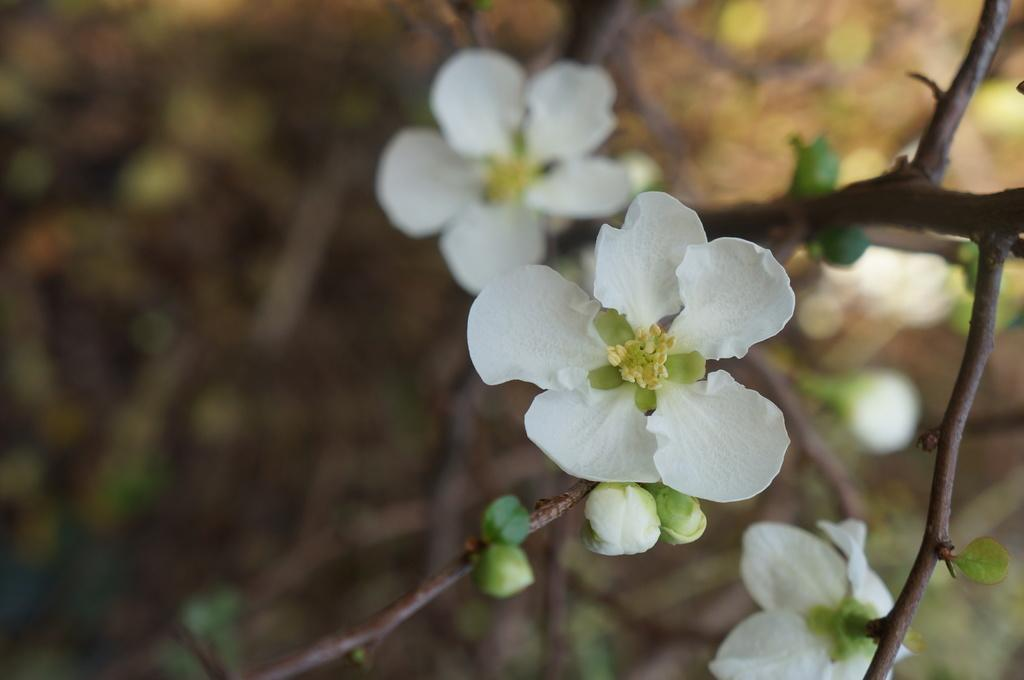What type of plants can be seen in the image? There are flowers in the image. What stage of growth are the plants in the tree? There are buds in a tree in the image. How would you describe the background of the image? The background of the image is blurred. How many pins are holding the flowers in place in the image? There are no pins visible in the image; the flowers are not being held in place. 